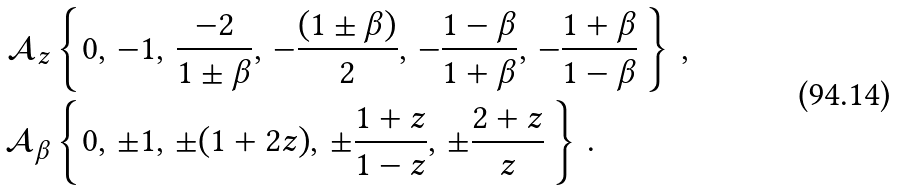<formula> <loc_0><loc_0><loc_500><loc_500>\mathcal { A } _ { z } & \left \{ 0 , \, - 1 , \, \frac { - 2 } { 1 \pm \beta } , \, - \frac { ( 1 \pm \beta ) } { 2 } , \, - \frac { 1 - \beta } { 1 + \beta } , \, - \frac { 1 + \beta } { 1 - \beta } \, \right \} \, , \\ \mathcal { A } _ { \beta } & \left \{ 0 , \, \pm 1 , \, \pm ( 1 + 2 z ) , \, \pm \frac { 1 + z } { 1 - z } , \, \pm \frac { 2 + z } { z } \, \right \} \, .</formula> 